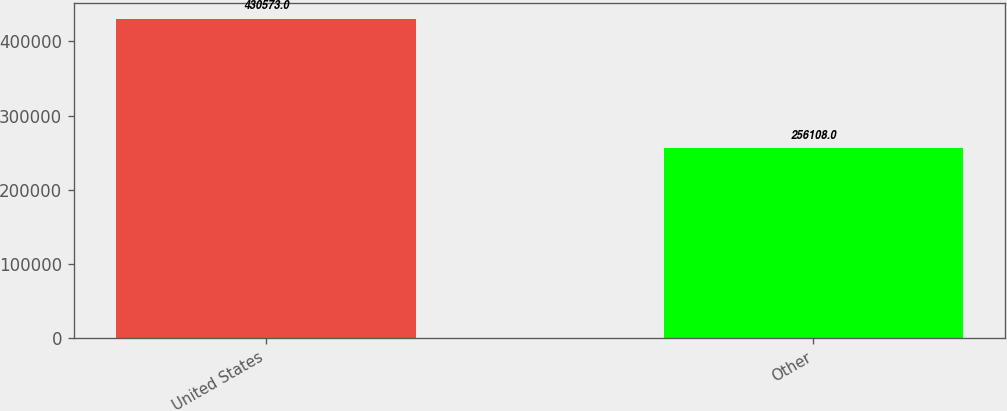Convert chart. <chart><loc_0><loc_0><loc_500><loc_500><bar_chart><fcel>United States<fcel>Other<nl><fcel>430573<fcel>256108<nl></chart> 